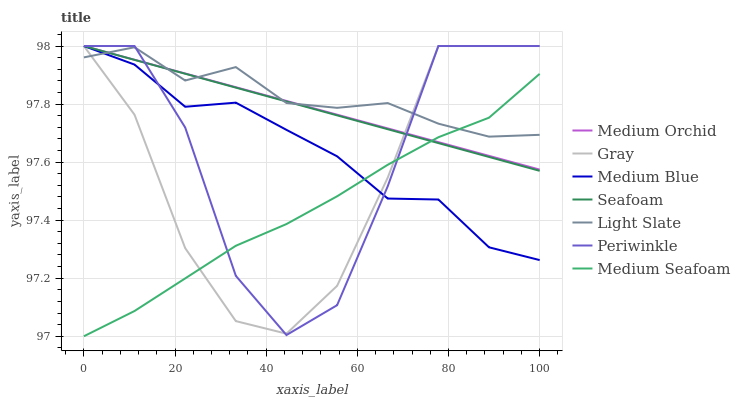Does Medium Seafoam have the minimum area under the curve?
Answer yes or no. Yes. Does Light Slate have the maximum area under the curve?
Answer yes or no. Yes. Does Medium Orchid have the minimum area under the curve?
Answer yes or no. No. Does Medium Orchid have the maximum area under the curve?
Answer yes or no. No. Is Medium Orchid the smoothest?
Answer yes or no. Yes. Is Periwinkle the roughest?
Answer yes or no. Yes. Is Light Slate the smoothest?
Answer yes or no. No. Is Light Slate the roughest?
Answer yes or no. No. Does Medium Orchid have the lowest value?
Answer yes or no. No. Does Periwinkle have the highest value?
Answer yes or no. Yes. Does Light Slate have the highest value?
Answer yes or no. No. Does Seafoam intersect Gray?
Answer yes or no. Yes. Is Seafoam less than Gray?
Answer yes or no. No. Is Seafoam greater than Gray?
Answer yes or no. No. 